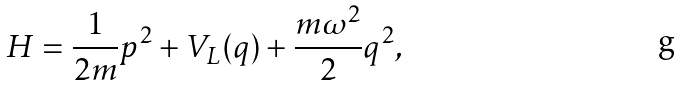<formula> <loc_0><loc_0><loc_500><loc_500>H = \frac { 1 } { 2 m } p ^ { 2 } + V _ { L } ( q ) + \frac { m \omega ^ { 2 } } { 2 } q ^ { 2 } ,</formula> 